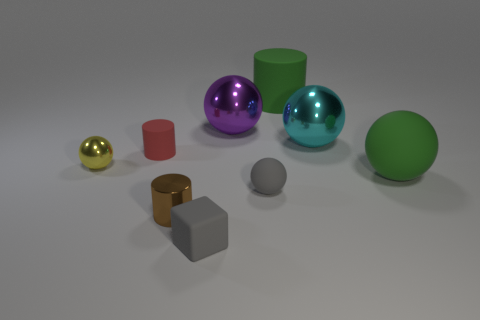Subtract 1 spheres. How many spheres are left? 4 Subtract all purple spheres. How many spheres are left? 4 Subtract all yellow balls. How many balls are left? 4 Subtract all blue spheres. Subtract all purple cylinders. How many spheres are left? 5 Subtract all blocks. How many objects are left? 8 Add 9 big cyan metal spheres. How many big cyan metal spheres exist? 10 Subtract 0 purple cubes. How many objects are left? 9 Subtract all red rubber objects. Subtract all big purple things. How many objects are left? 7 Add 7 gray rubber things. How many gray rubber things are left? 9 